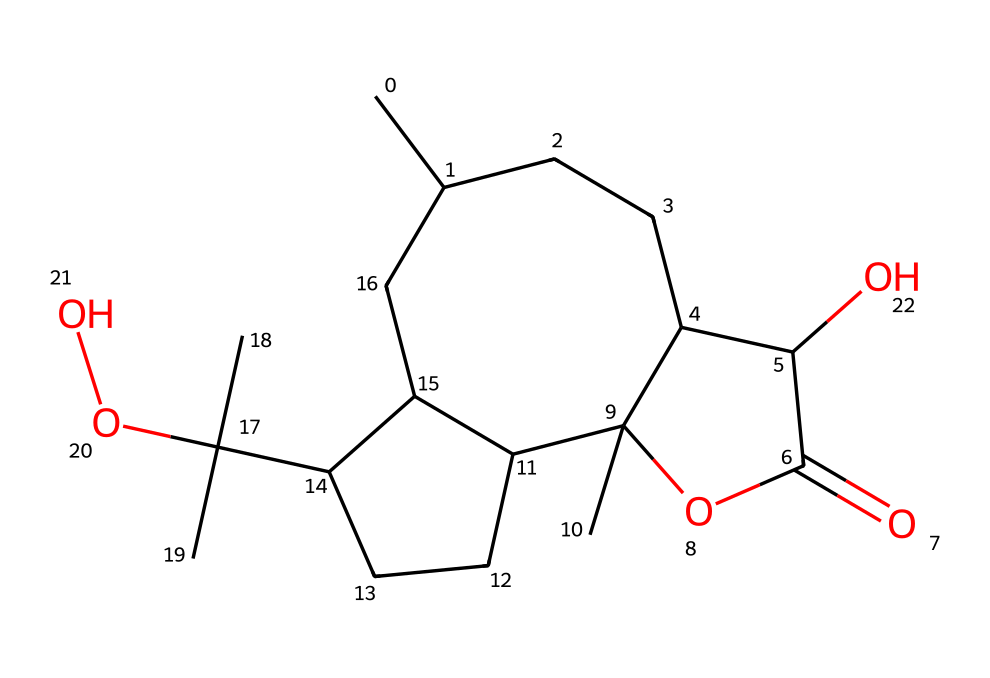What is the total number of carbons in this structure? By analyzing the SMILES representation, you can count the number of 'C' symbols which represent carbon atoms. In this case, there are a total of 15 carbons present.
Answer: 15 How many oxygen atoms are in the structure? In the SMILES, the 'O' symbols correspond to oxygen atoms. Counting them, we find there are 3 oxygen atoms in total.
Answer: 3 What functional group is present due to the presence of the -OH group? The presence of the -OH group indicates that the compound has alcohol functionality. This can be identified by looking for the presence of single-bonded oxygen to hydrogen in the structure.
Answer: alcohol Which element is primarily responsible for the structural properties of artemisinin? The backbone primarily consists of carbon, but the oxygen atoms play a critical role in the functional properties associated with its medicinal effects. The compound relies heavily on its carbon framework combined with the distinctive arrangement of the oxygens for its efficacy as an antimalarial agent.
Answer: carbon What is the type of isomerism displayed in artemisinin? This compound exhibits stereoisomerism due to the presence of multiple chiral centers in its structure as indicated by the branching points and substituent attachments which each can have different spatial arrangements.
Answer: stereoisomerism What type of medicinal activity does artemisinin possess? The structure suggests that artemisinin has antimalarial activity, as it is specifically derived from traditional medicine known for treating malaria. This connection can be traced back to the historical use of artemisia plants in herbal remedies against malaria.
Answer: antimalarial 